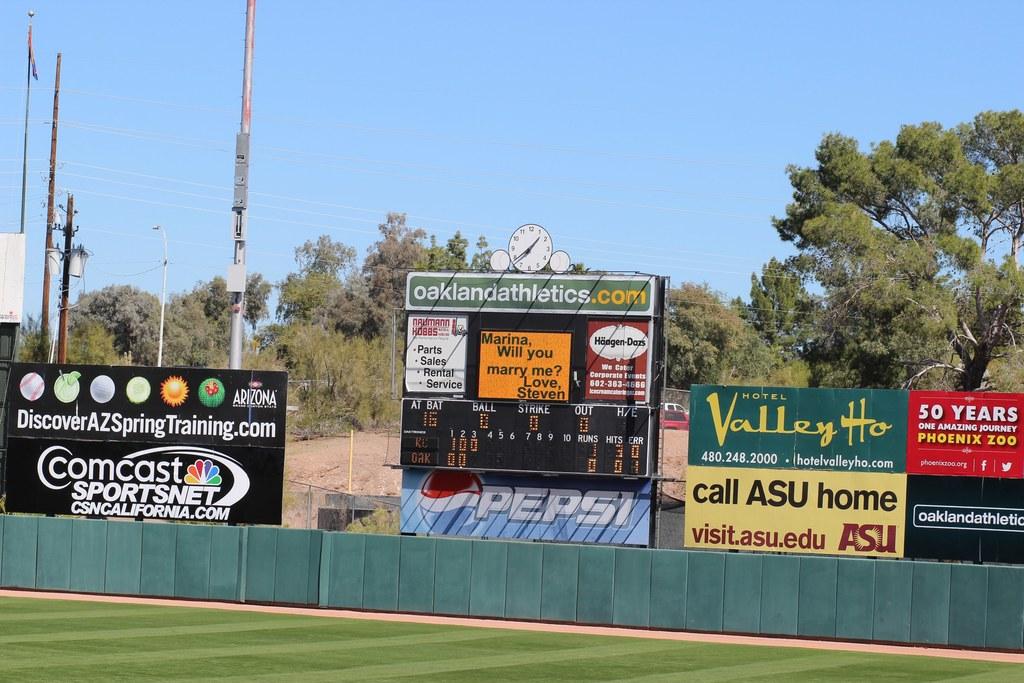How long has the zoo been open?
Give a very brief answer. 50 years. What can you call home?
Provide a succinct answer. Asu. 